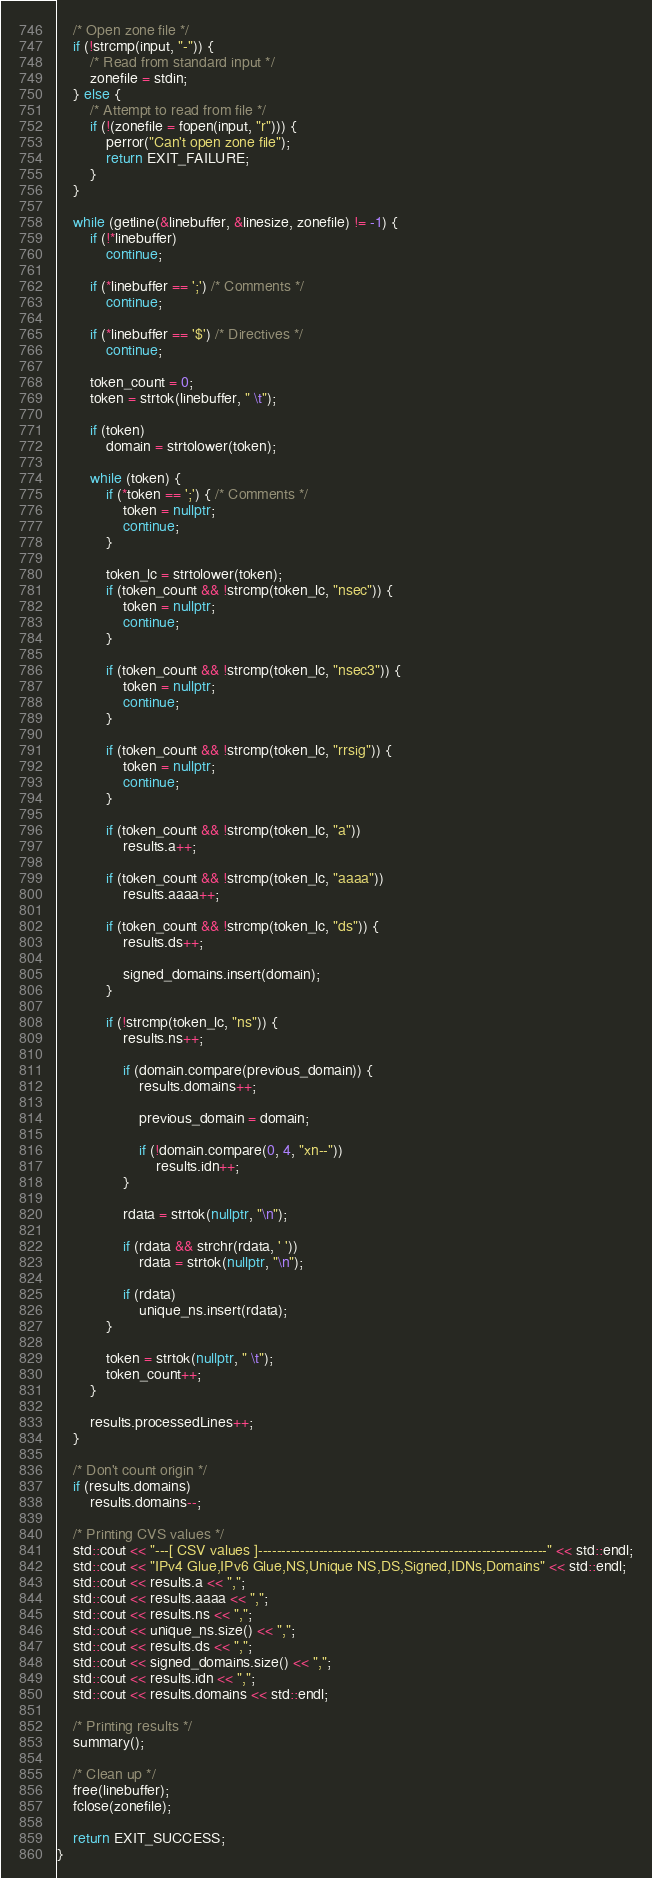<code> <loc_0><loc_0><loc_500><loc_500><_C++_>	/* Open zone file */
	if (!strcmp(input, "-")) {
		/* Read from standard input */
		zonefile = stdin;
	} else {
		/* Attempt to read from file */
		if (!(zonefile = fopen(input, "r"))) {
			perror("Can't open zone file");
			return EXIT_FAILURE;
		}
	}

	while (getline(&linebuffer, &linesize, zonefile) != -1) {
		if (!*linebuffer)
			continue;

		if (*linebuffer == ';') /* Comments */
			continue;

		if (*linebuffer == '$') /* Directives */
			continue;

		token_count = 0;
		token = strtok(linebuffer, " \t");

		if (token)
			domain = strtolower(token);

		while (token) {
			if (*token == ';') { /* Comments */
				token = nullptr;
				continue;
			}

			token_lc = strtolower(token);
			if (token_count && !strcmp(token_lc, "nsec")) {
				token = nullptr;
				continue;
			}

			if (token_count && !strcmp(token_lc, "nsec3")) {
				token = nullptr;
				continue;
			}

			if (token_count && !strcmp(token_lc, "rrsig")) {
				token = nullptr;
				continue;
			}

			if (token_count && !strcmp(token_lc, "a"))
				results.a++;

			if (token_count && !strcmp(token_lc, "aaaa"))
				results.aaaa++;

			if (token_count && !strcmp(token_lc, "ds")) {
				results.ds++;

				signed_domains.insert(domain);
			}

			if (!strcmp(token_lc, "ns")) {
				results.ns++;

				if (domain.compare(previous_domain)) {
					results.domains++;

					previous_domain = domain;

					if (!domain.compare(0, 4, "xn--"))
						results.idn++;
				}

				rdata = strtok(nullptr, "\n");

				if (rdata && strchr(rdata, ' '))
					rdata = strtok(nullptr, "\n");

				if (rdata)
					unique_ns.insert(rdata);
			}

			token = strtok(nullptr, " \t");
			token_count++;
		}

		results.processedLines++;
	}

	/* Don't count origin */
	if (results.domains)
		results.domains--;

	/* Printing CVS values */
	std::cout << "---[ CSV values ]--------------------------------------------------------------" << std::endl;
	std::cout << "IPv4 Glue,IPv6 Glue,NS,Unique NS,DS,Signed,IDNs,Domains" << std::endl;
	std::cout << results.a << ",";
	std::cout << results.aaaa << ",";
	std::cout << results.ns << ",";
	std::cout << unique_ns.size() << ",";
	std::cout << results.ds << ",";
	std::cout << signed_domains.size() << ",";
	std::cout << results.idn << ",";
	std::cout << results.domains << std::endl;

	/* Printing results */
	summary();

	/* Clean up */
	free(linebuffer);
	fclose(zonefile);

	return EXIT_SUCCESS;
}
</code> 